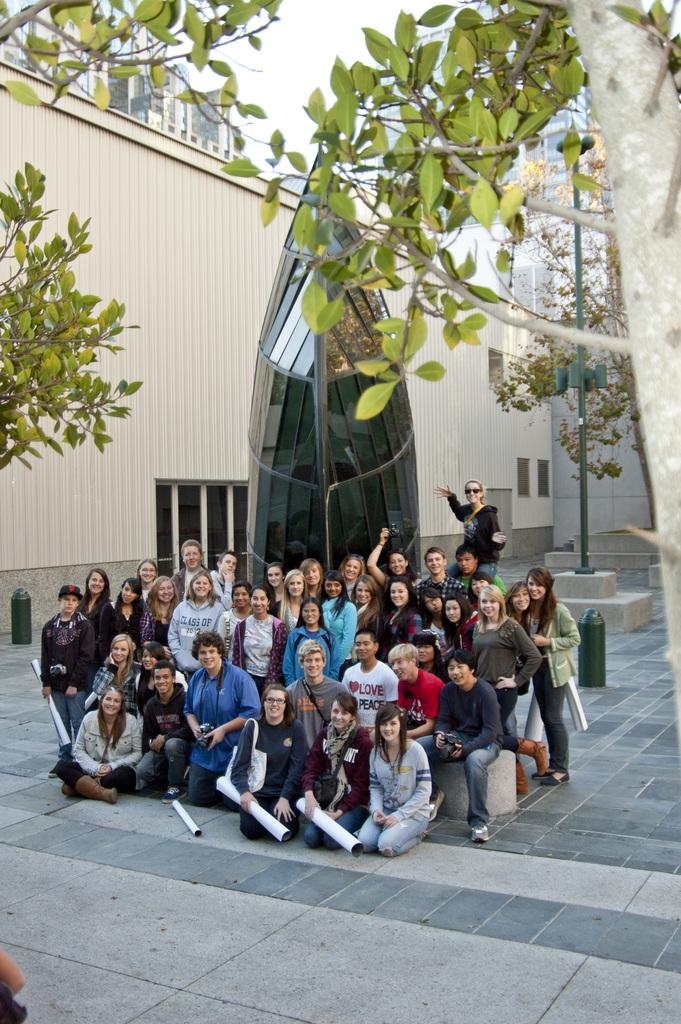What are the people in the center of the image doing? There are people sitting and standing in the center of the image. What can be seen in the background of the image? There are trees, buildings, and a monument in the background of the image. How many pizzas are being held by the children in the image? There are no children or pizzas present in the image. 